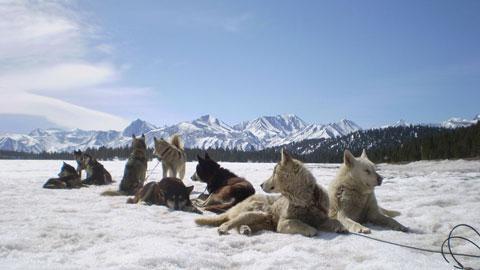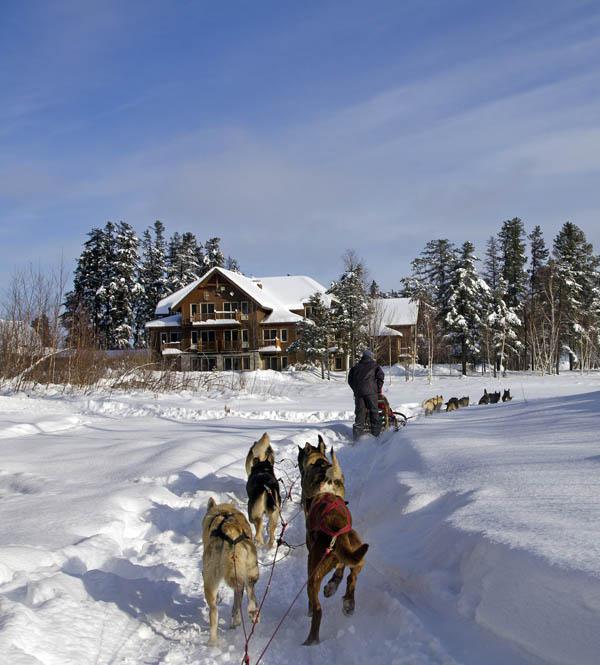The first image is the image on the left, the second image is the image on the right. For the images shown, is this caption "A building with a snow-covered peaked roof is in the background of an image with at least one sled dog team racing across the snow." true? Answer yes or no. Yes. 